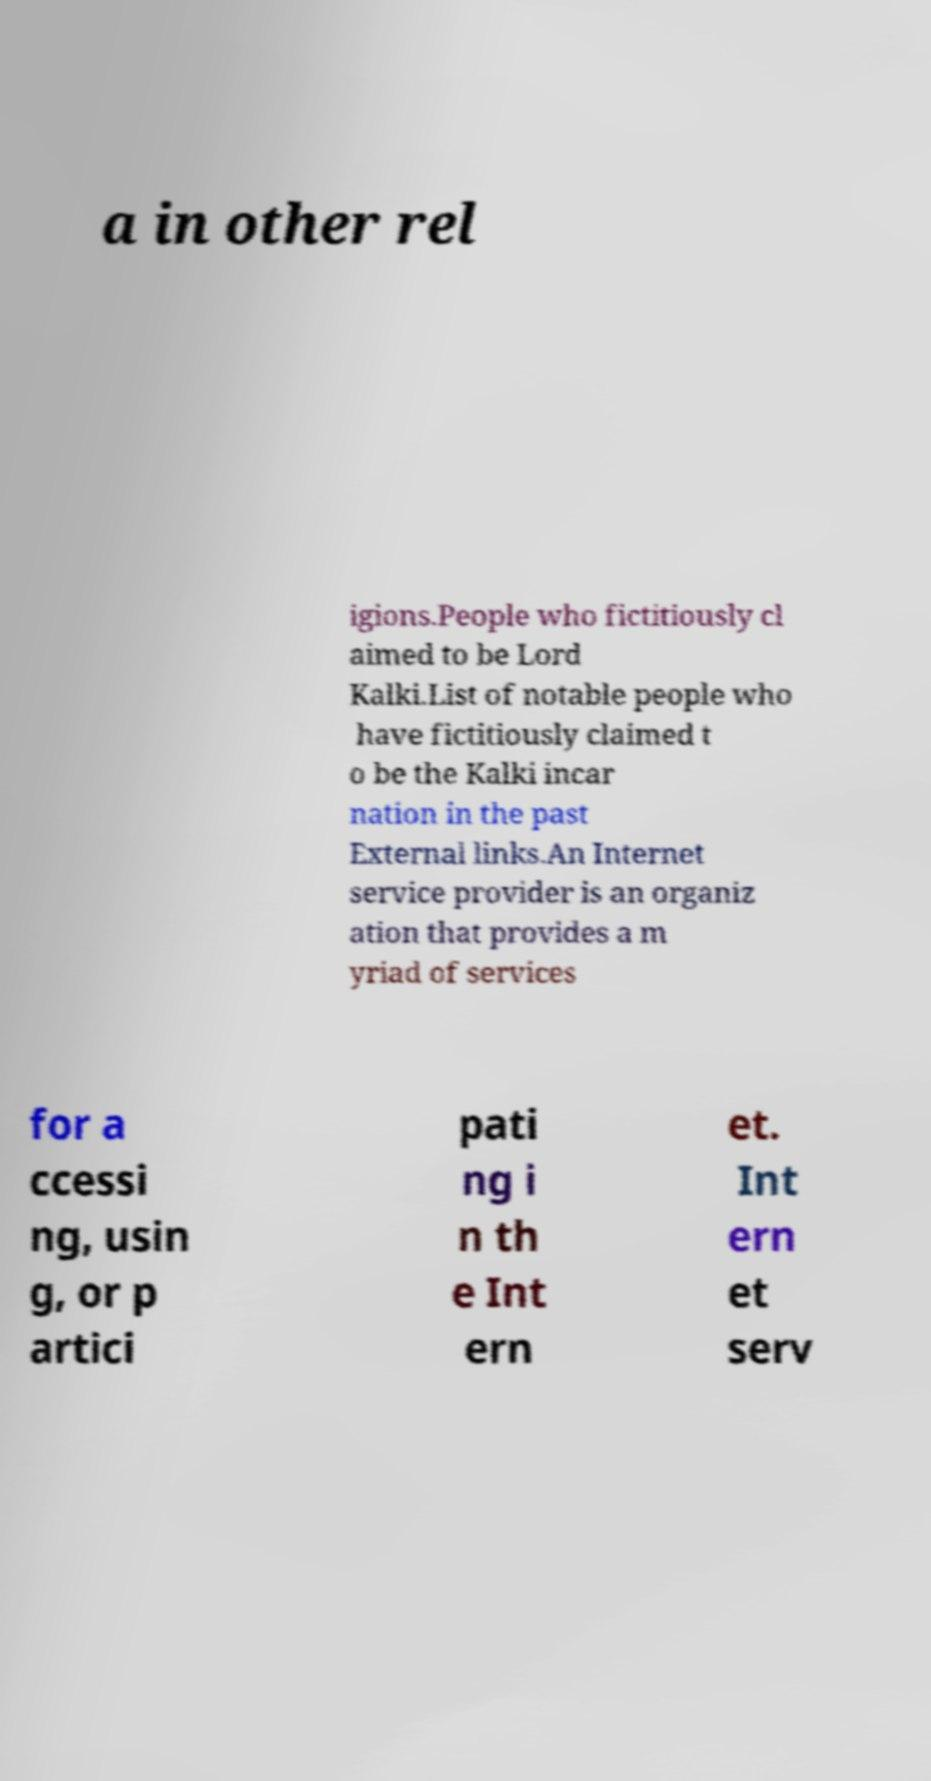Can you read and provide the text displayed in the image?This photo seems to have some interesting text. Can you extract and type it out for me? a in other rel igions.People who fictitiously cl aimed to be Lord Kalki.List of notable people who have fictitiously claimed t o be the Kalki incar nation in the past External links.An Internet service provider is an organiz ation that provides a m yriad of services for a ccessi ng, usin g, or p artici pati ng i n th e Int ern et. Int ern et serv 